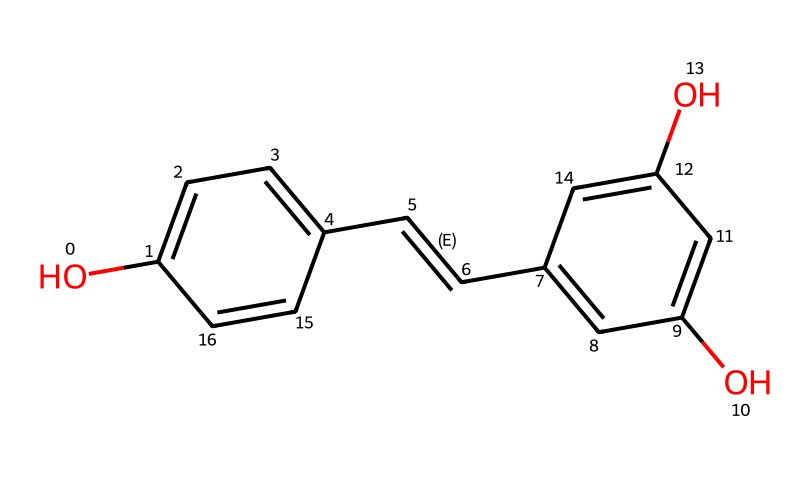What is the molecular formula of resveratrol? By analyzing the provided structure, the atoms can be counted: there are 14 carbons, 12 hydrogens, and 4 oxygens, leading to the molecular formula C14H12O4.
Answer: C14H12O4 How many hydroxyl groups are present in the structure of resveratrol? The structure shows two -OH (hydroxyl) groups attached to the benzene rings, which can be easily identified.
Answer: 2 What type of chemical bonding is prevalent in the resveratrol structure? The structure features carbon-carbon double bonds and various single bonds, primarily indicating the presence of covalent bonding, which is typical for organic compounds.
Answer: covalent What is the main functional group in resveratrol? The presence of the -OH groups indicates that the main functional group is phenolic, common to phenolic compounds.
Answer: phenolic How many rings are present in the structure of resveratrol? The visual representation shows two aromatic rings fused with a double bond in between, counting as two distinct rings in the structure.
Answer: 2 What characteristic property does resveratrol confer due to its structure? The arrangement of hydroxyl groups and the presence of double bonds contribute to its antioxidant properties, making it effective in neutralizing free radicals.
Answer: antioxidant What is the significance of the trans double bond in resveratrol? The trans configuration affects the spatial arrangement of substituents, influencing its biological activity and stability compared to cis isomers, thus playing a crucial role in its function.
Answer: biological activity 